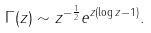<formula> <loc_0><loc_0><loc_500><loc_500>\Gamma ( z ) \sim z ^ { - \frac { 1 } { 2 } } e ^ { z ( \log z - 1 ) } .</formula> 